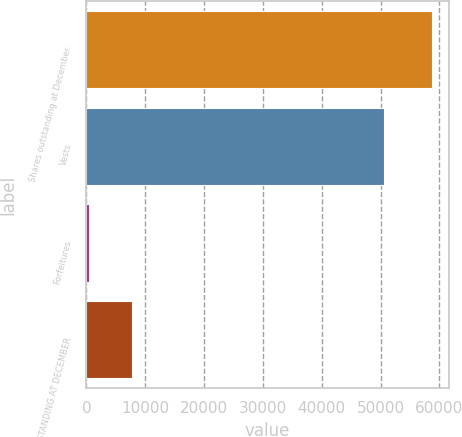Convert chart. <chart><loc_0><loc_0><loc_500><loc_500><bar_chart><fcel>Shares outstanding at December<fcel>Vests<fcel>Forfeitures<fcel>SHARES OUTSTANDING AT DECEMBER<nl><fcel>58661<fcel>50538<fcel>438<fcel>7685<nl></chart> 